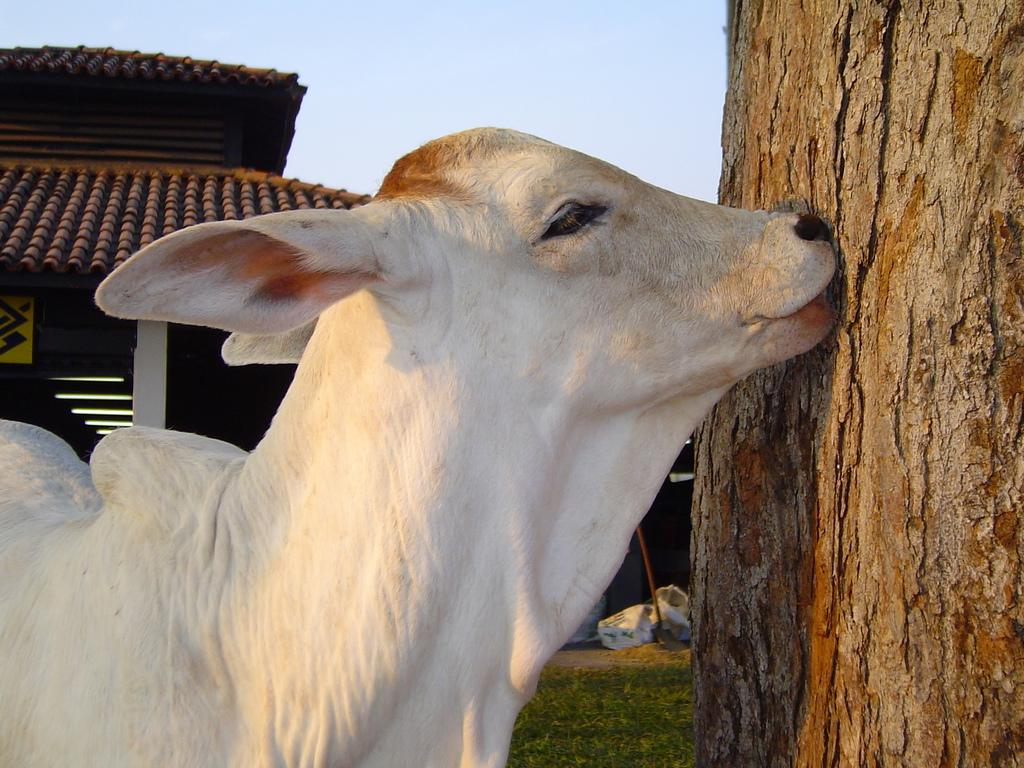What type of animal is in the image? There is an animal in the image, but the specific type cannot be determined from the provided facts. What is the animal standing near in the image? There is a tree trunk in the image, and the animal appears to be standing near it. What structure can be seen in the top left corner of the image? There appears to be a shelter in the top left corner of the image. What else can be seen in the image besides the animal, tree trunk, and shelter? There are other objects in the image, but their specific nature cannot be determined from the provided facts. What is visible in the background of the image? The sky is visible in the background of the image. What type of coil is being used to create the powder in the image? There is no coil or powder present in the image. What type of agreement is being made between the animal and the tree trunk in the image? There is no agreement being made between the animal and the tree trunk in the image. 